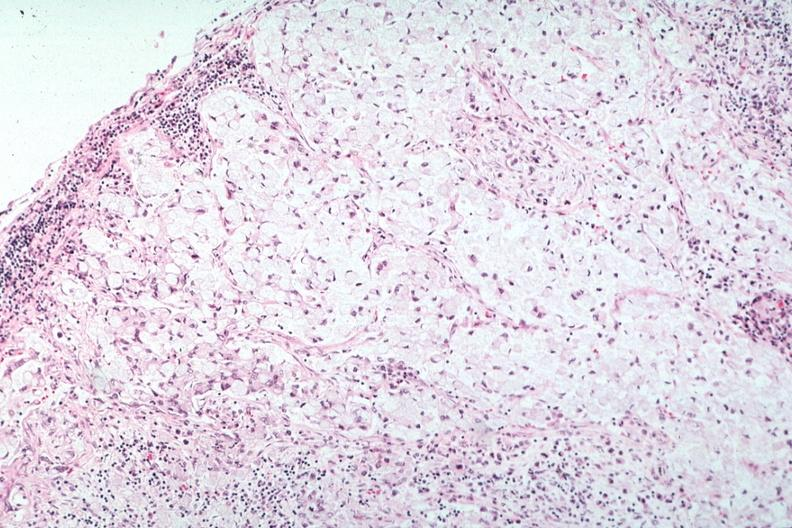s lymph node present?
Answer the question using a single word or phrase. Yes 